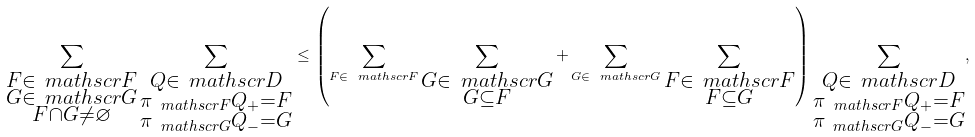Convert formula to latex. <formula><loc_0><loc_0><loc_500><loc_500>\sum _ { \substack { F \in \ m a t h s c r { F } \\ G \in \ m a t h s c r { G } \\ F \cap G \neq \varnothing } } \sum _ { \substack { Q \in \ m a t h s c r { D } \\ \pi _ { \ m a t h s c r { F } } Q _ { + } = F \\ \pi _ { \ m a t h s c r { G } } Q _ { - } = G } } \leq \left ( \sum _ { F \in \ m a t h s c r { F } } \sum _ { \substack { G \in \ m a t h s c r { G } \\ G \subseteq F } } + \sum _ { G \in \ m a t h s c r { G } } \sum _ { \substack { F \in \ m a t h s c r { F } \\ F \subseteq G } } \right ) \sum _ { \substack { Q \in \ m a t h s c r { D } \\ \pi _ { \ m a t h s c r { F } } Q _ { + } = F \\ \pi _ { \ m a t h s c r { G } } Q _ { - } = G } } ,</formula> 